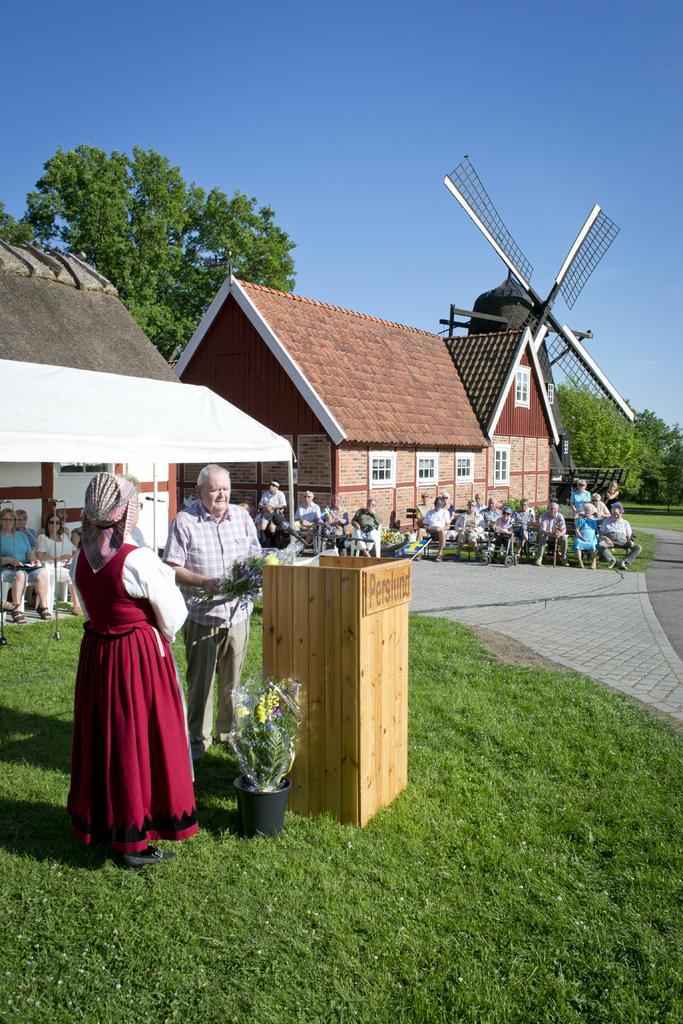Please provide a concise description of this image. This picture describes about group of people, few are seated on the chairs and few are standing, in the middle of the image we can see a podium and a flower pot on the grass, in the background we can see few houses and trees. 